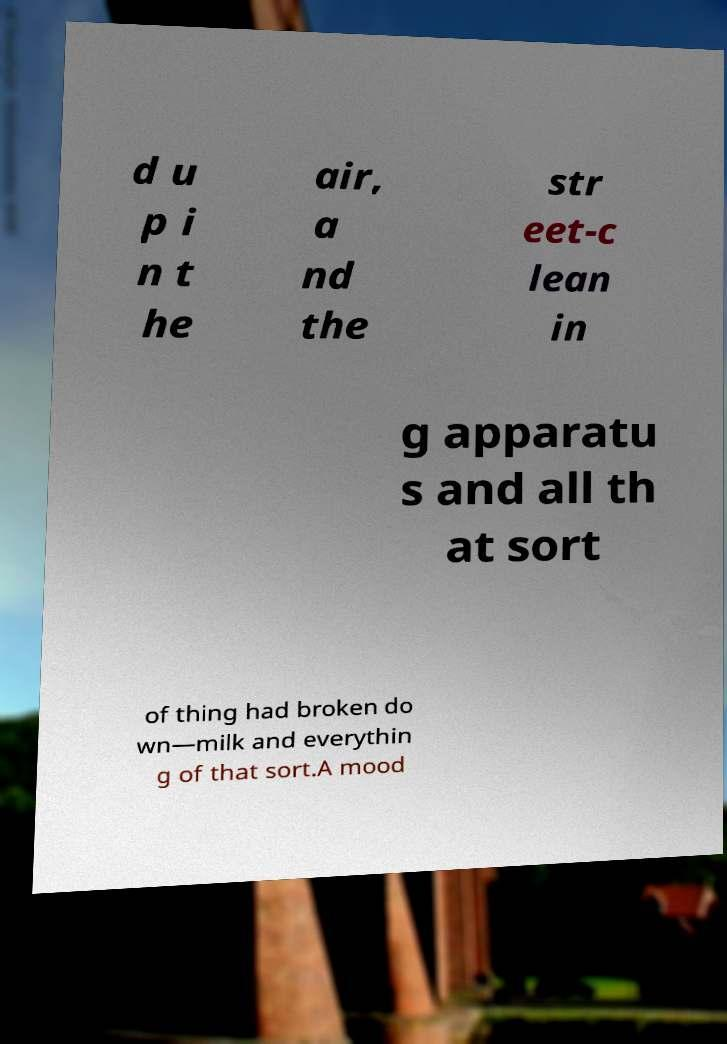Please read and relay the text visible in this image. What does it say? d u p i n t he air, a nd the str eet-c lean in g apparatu s and all th at sort of thing had broken do wn—milk and everythin g of that sort.A mood 